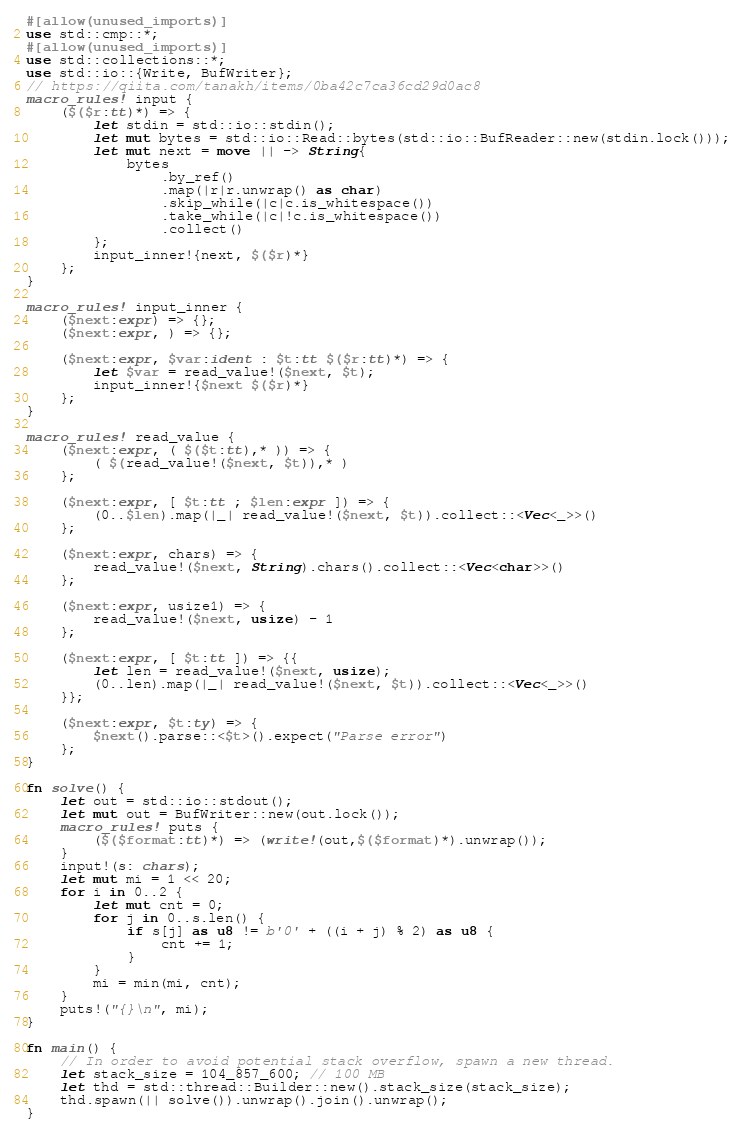Convert code to text. <code><loc_0><loc_0><loc_500><loc_500><_Rust_>#[allow(unused_imports)]
use std::cmp::*;
#[allow(unused_imports)]
use std::collections::*;
use std::io::{Write, BufWriter};
// https://qiita.com/tanakh/items/0ba42c7ca36cd29d0ac8
macro_rules! input {
    ($($r:tt)*) => {
        let stdin = std::io::stdin();
        let mut bytes = std::io::Read::bytes(std::io::BufReader::new(stdin.lock()));
        let mut next = move || -> String{
            bytes
                .by_ref()
                .map(|r|r.unwrap() as char)
                .skip_while(|c|c.is_whitespace())
                .take_while(|c|!c.is_whitespace())
                .collect()
        };
        input_inner!{next, $($r)*}
    };
}

macro_rules! input_inner {
    ($next:expr) => {};
    ($next:expr, ) => {};

    ($next:expr, $var:ident : $t:tt $($r:tt)*) => {
        let $var = read_value!($next, $t);
        input_inner!{$next $($r)*}
    };
}

macro_rules! read_value {
    ($next:expr, ( $($t:tt),* )) => {
        ( $(read_value!($next, $t)),* )
    };

    ($next:expr, [ $t:tt ; $len:expr ]) => {
        (0..$len).map(|_| read_value!($next, $t)).collect::<Vec<_>>()
    };

    ($next:expr, chars) => {
        read_value!($next, String).chars().collect::<Vec<char>>()
    };

    ($next:expr, usize1) => {
        read_value!($next, usize) - 1
    };

    ($next:expr, [ $t:tt ]) => {{
        let len = read_value!($next, usize);
        (0..len).map(|_| read_value!($next, $t)).collect::<Vec<_>>()
    }};

    ($next:expr, $t:ty) => {
        $next().parse::<$t>().expect("Parse error")
    };
}

fn solve() {
    let out = std::io::stdout();
    let mut out = BufWriter::new(out.lock());
    macro_rules! puts {
        ($($format:tt)*) => (write!(out,$($format)*).unwrap());
    }
    input!(s: chars);
    let mut mi = 1 << 20;
    for i in 0..2 {
        let mut cnt = 0;
        for j in 0..s.len() {
            if s[j] as u8 != b'0' + ((i + j) % 2) as u8 {
                cnt += 1;
            }
        }
        mi = min(mi, cnt);
    }
    puts!("{}\n", mi);
}

fn main() {
    // In order to avoid potential stack overflow, spawn a new thread.
    let stack_size = 104_857_600; // 100 MB
    let thd = std::thread::Builder::new().stack_size(stack_size);
    thd.spawn(|| solve()).unwrap().join().unwrap();
}
</code> 